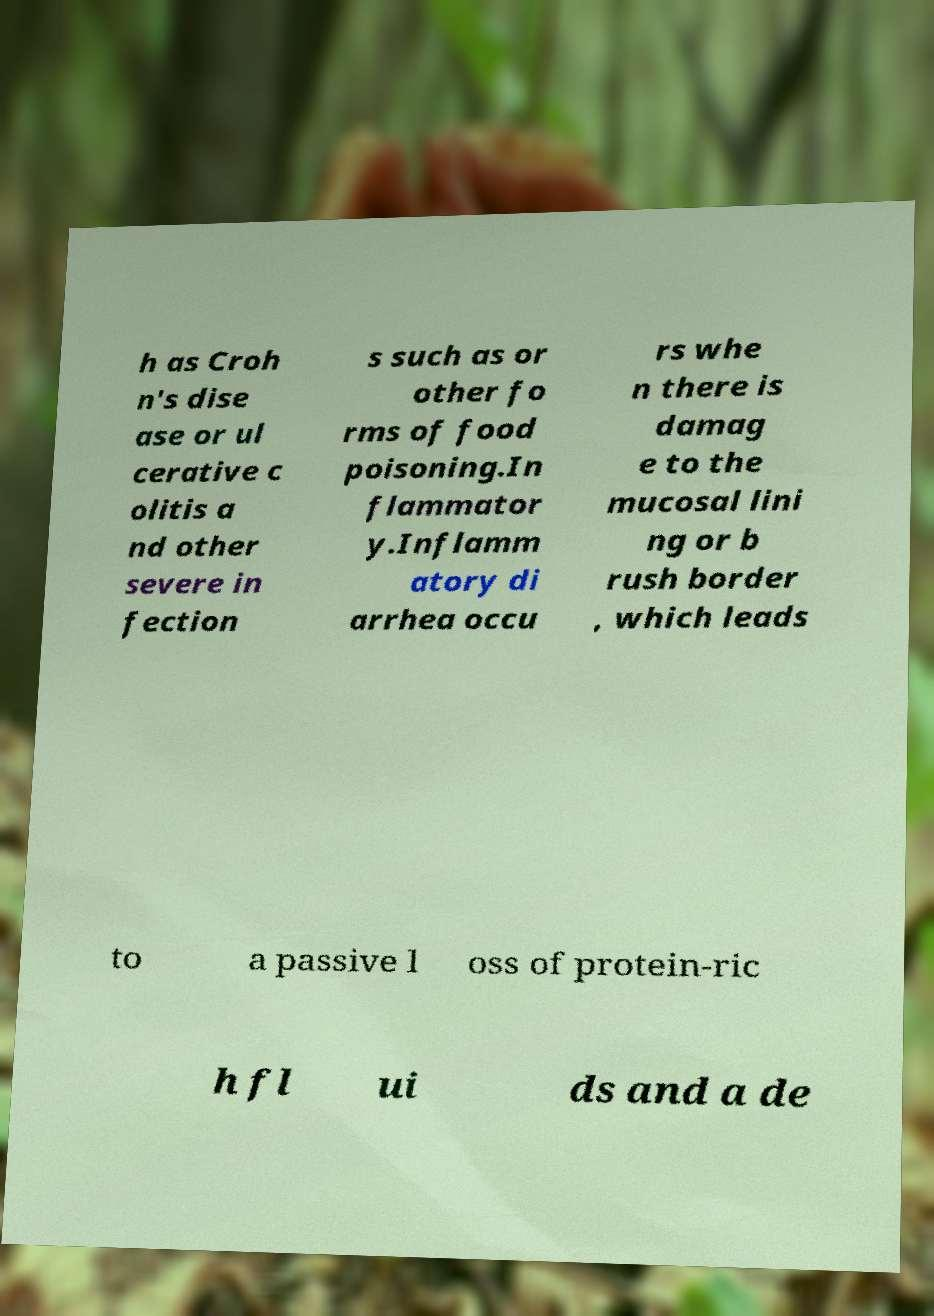What messages or text are displayed in this image? I need them in a readable, typed format. h as Croh n's dise ase or ul cerative c olitis a nd other severe in fection s such as or other fo rms of food poisoning.In flammator y.Inflamm atory di arrhea occu rs whe n there is damag e to the mucosal lini ng or b rush border , which leads to a passive l oss of protein-ric h fl ui ds and a de 